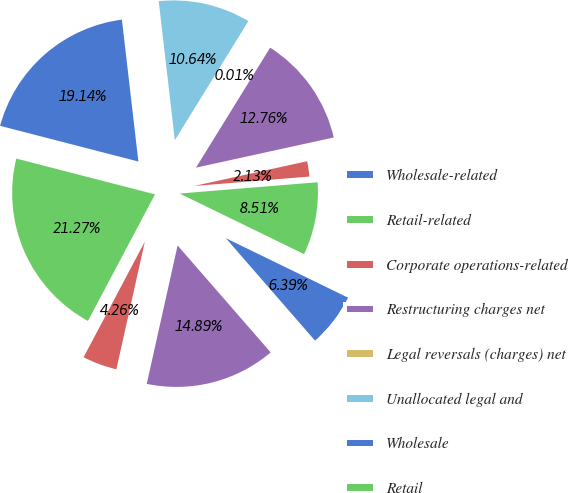<chart> <loc_0><loc_0><loc_500><loc_500><pie_chart><fcel>Wholesale-related<fcel>Retail-related<fcel>Corporate operations-related<fcel>Restructuring charges net<fcel>Legal reversals (charges) net<fcel>Unallocated legal and<fcel>Wholesale<fcel>Retail<fcel>Licensing<fcel>Unallocated corporate expenses<nl><fcel>6.39%<fcel>8.51%<fcel>2.13%<fcel>12.76%<fcel>0.01%<fcel>10.64%<fcel>19.14%<fcel>21.27%<fcel>4.26%<fcel>14.89%<nl></chart> 